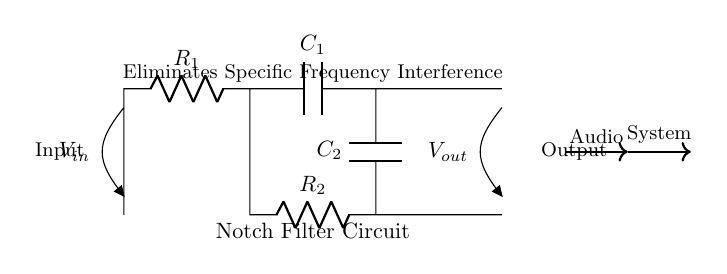What are the two types of components found in this circuit? The circuit contains resistors and capacitors, identifiable by the symbols R and C next to the arrows representing the components.
Answer: Resistors and capacitors Which component acts as the input in this circuit? The input is marked as V in the circuit diagram, which indicates the point where the audio signal enters the filter.
Answer: V_in How many resistors are in this notch filter circuit? By examining the circuit, there are two components clearly labeled as resistors (R1 and R2) indicating the total count.
Answer: 2 What is the main purpose of this circuit? The title of the diagram specifies that the circuit’s purpose is to eliminate specific frequency interference in audio systems, indicating its functional role.
Answer: Eliminate specific frequency interference What is the output of this circuit? The output voltage is indicated as V_out, showing the point where the filtered audio signal leaves the circuit after interference removal.
Answer: V_out Why is a notch filter used in audio systems? A notch filter is employed to specifically target and eliminate unwanted frequency components from audio signals, enhancing clarity by reducing noise.
Answer: To eliminate unwanted frequencies What frequency range does this filter impact? While the diagram does not specify an exact frequency, notch filters are designed to target specific frequency bands, which must be chosen based on the interference being addressed.
Answer: Specific frequency range 